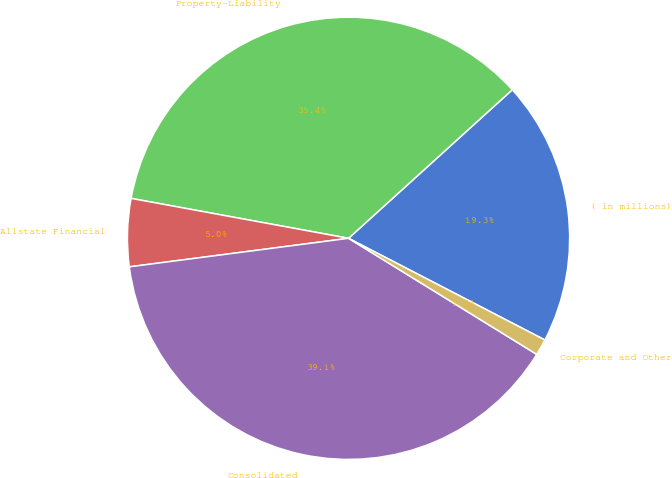Convert chart. <chart><loc_0><loc_0><loc_500><loc_500><pie_chart><fcel>( in millions)<fcel>Property-Liability<fcel>Allstate Financial<fcel>Consolidated<fcel>Corporate and Other<nl><fcel>19.33%<fcel>35.38%<fcel>4.95%<fcel>39.14%<fcel>1.19%<nl></chart> 